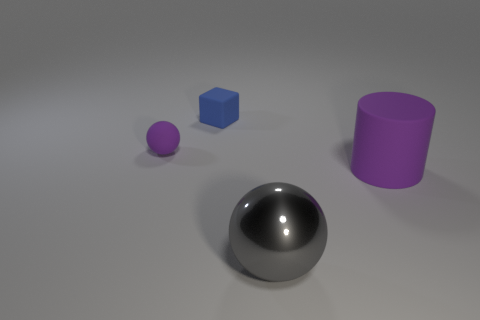Add 3 large purple matte cylinders. How many objects exist? 7 Subtract all gray shiny spheres. Subtract all tiny shiny blocks. How many objects are left? 3 Add 1 small spheres. How many small spheres are left? 2 Add 1 small yellow metal cylinders. How many small yellow metal cylinders exist? 1 Subtract 0 yellow cylinders. How many objects are left? 4 